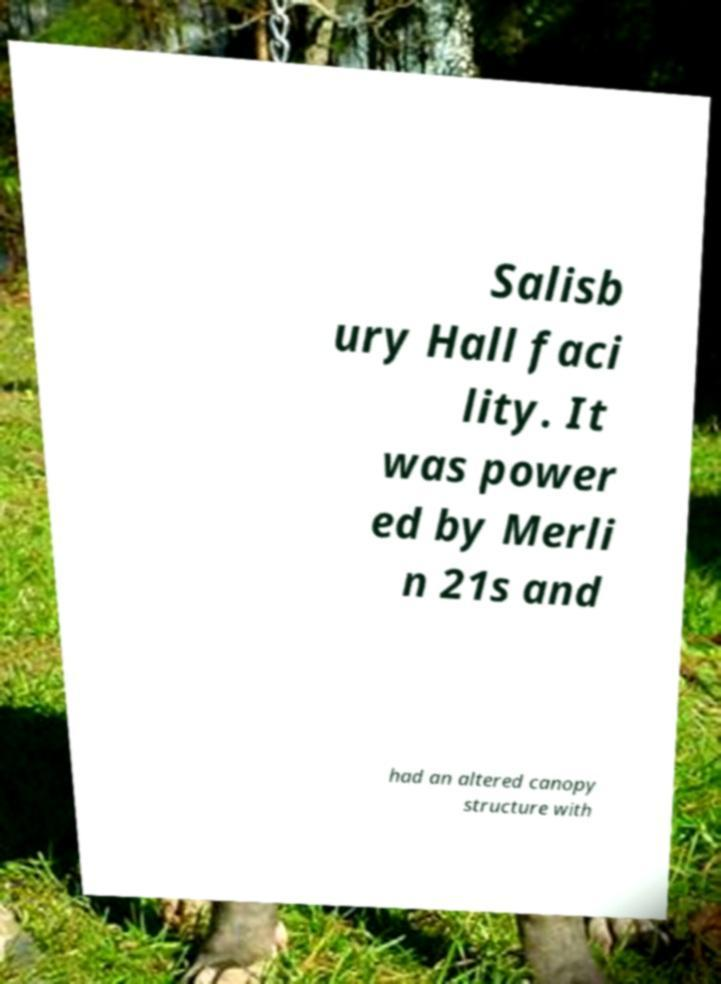For documentation purposes, I need the text within this image transcribed. Could you provide that? Salisb ury Hall faci lity. It was power ed by Merli n 21s and had an altered canopy structure with 